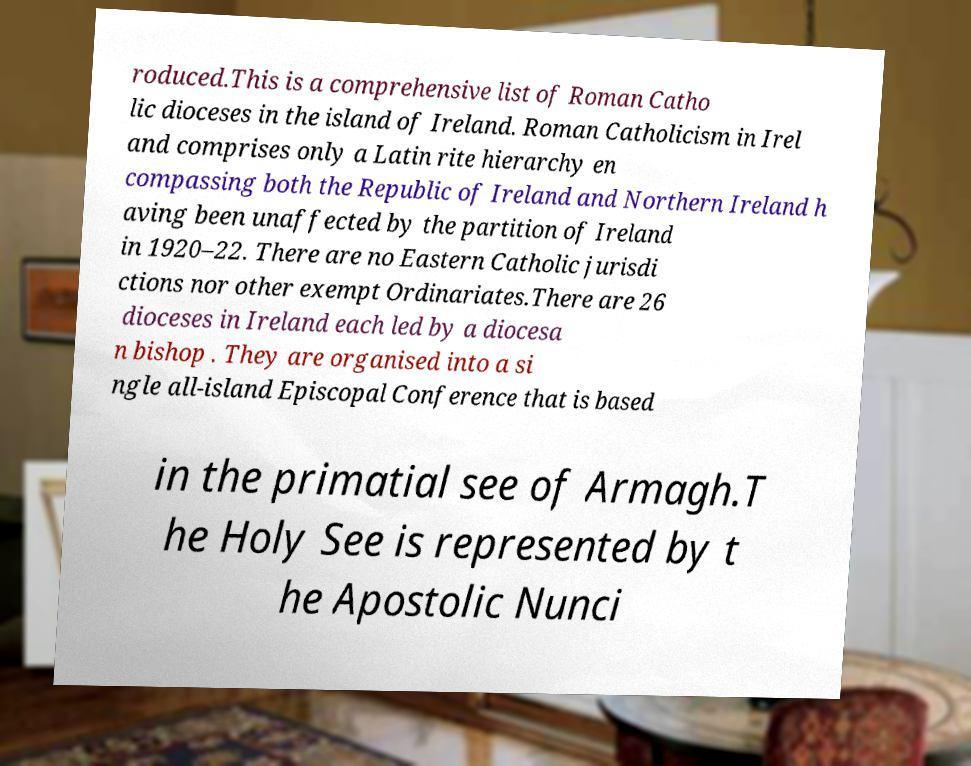Could you extract and type out the text from this image? roduced.This is a comprehensive list of Roman Catho lic dioceses in the island of Ireland. Roman Catholicism in Irel and comprises only a Latin rite hierarchy en compassing both the Republic of Ireland and Northern Ireland h aving been unaffected by the partition of Ireland in 1920–22. There are no Eastern Catholic jurisdi ctions nor other exempt Ordinariates.There are 26 dioceses in Ireland each led by a diocesa n bishop . They are organised into a si ngle all-island Episcopal Conference that is based in the primatial see of Armagh.T he Holy See is represented by t he Apostolic Nunci 